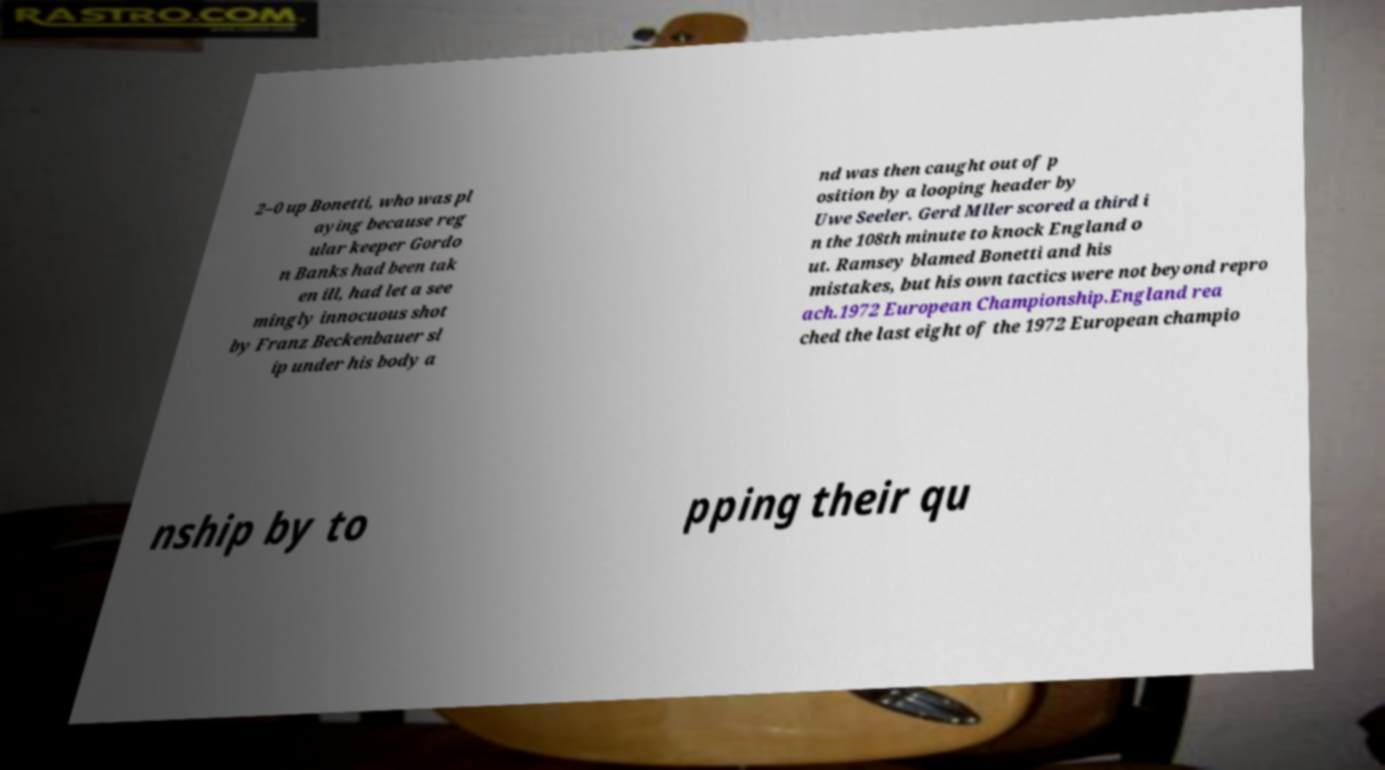What messages or text are displayed in this image? I need them in a readable, typed format. 2–0 up Bonetti, who was pl aying because reg ular keeper Gordo n Banks had been tak en ill, had let a see mingly innocuous shot by Franz Beckenbauer sl ip under his body a nd was then caught out of p osition by a looping header by Uwe Seeler. Gerd Mller scored a third i n the 108th minute to knock England o ut. Ramsey blamed Bonetti and his mistakes, but his own tactics were not beyond repro ach.1972 European Championship.England rea ched the last eight of the 1972 European champio nship by to pping their qu 